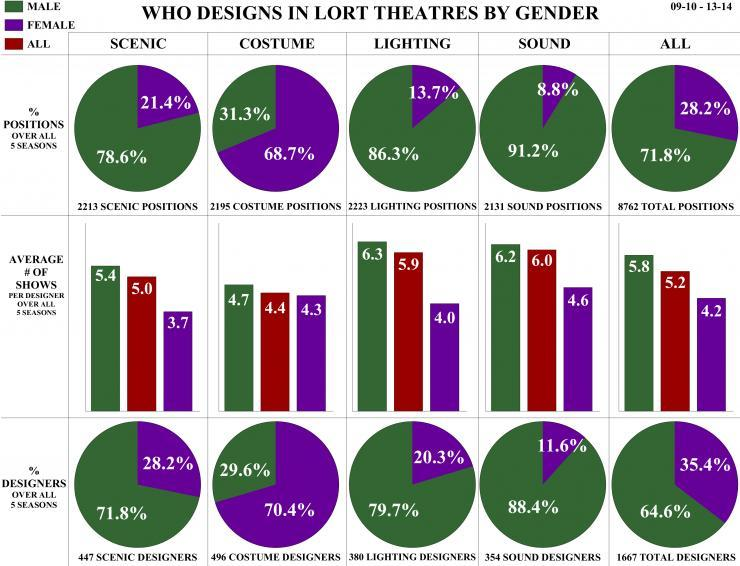What percentage of Males are Lighting Designers?
Answer the question with a short phrase. 79.7% What is the percentage of Male in costume positions? 31.3% What percentage of Females are Total Designers? 35.4% What is the percentage of Female in scenic positions? 21.4% What percentage of Males are Sound Designers? 88.4% What percentage of Males are in sound positions? 91.2% What percentage of Females are Costume Designers? 70.4% What is the percentage of Male in lighting positions? 86.3% What percentage of Females are in total positions? 28.2% What percentage of Males are Scenic Designers? 71.8% 